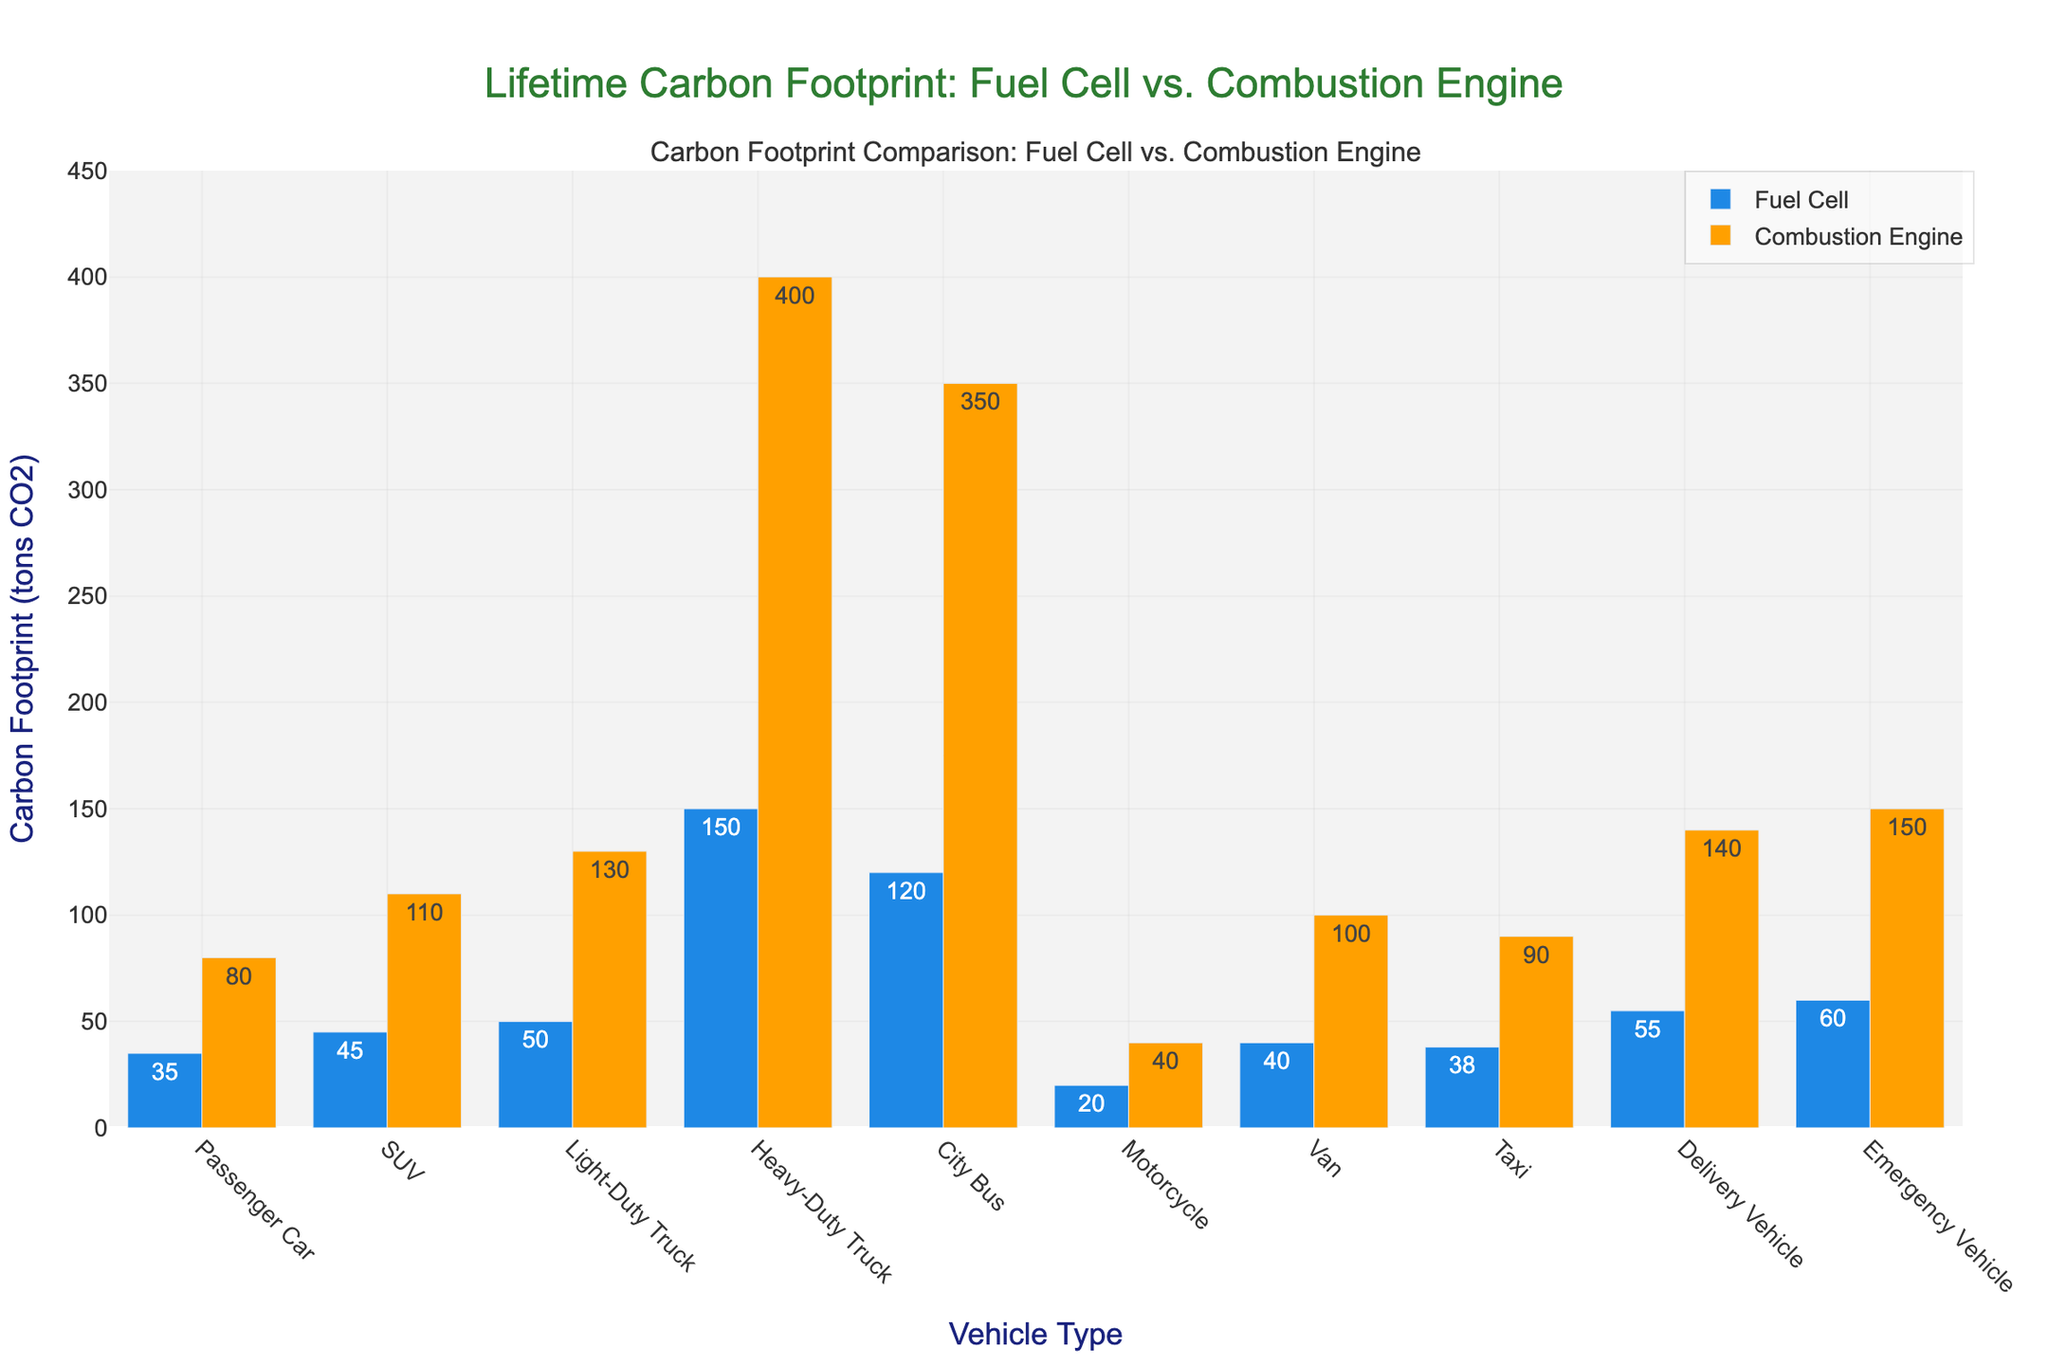What is the total carbon footprint of a fuel cell City Bus and an Emergency Vehicle combined? Sum the carbon footprint of fuel cell City Bus (120 tons CO2) and Emergency Vehicle (60 tons CO2): 120 + 60 = 180
Answer: 180 Which vehicle type shows the greatest difference in carbon footprint between fuel cell technology and combustion engine? Compare the differences for each vehicle type. Heavy-Duty Truck has the largest difference: 400 (Combustion Engine) - 150 (Fuel Cell) = 250
Answer: Heavy-Duty Truck How much more carbon does an SUV with a combustion engine emit over its lifetime compared to an SUV with a fuel cell? Subtract the carbon footprint of a fuel cell SUV (45 tons CO2) from a combustion engine SUV (110 tons CO2): 110 - 45 = 65
Answer: 65 What is the average carbon footprint of fuel cell vehicles for Passenger Car, SUV, and Light-Duty Truck? Sum the carbon footprints of these fuel cell vehicles: Passenger Car (35) + SUV (45) + Light-Duty Truck (50) = 130. Divide by 3: 130 / 3 ≈ 43.33
Answer: 43.33 Which vehicle type has the smallest carbon footprint for both fuel cell and combustion engine? Check the carbon footprints for both fuel cell and combustion engine across all vehicle types. Motorcycle has the smallest values: 20 (Fuel Cell) and 40 (Combustion Engine)
Answer: Motorcycle Between which vehicle types is the visual height difference of the bars (fuel cell vs. combustion engine) most noticeable? Visually compare bar heights for each vehicle type. Heavy-Duty Truck exhibits the most noticeable height difference with a difference of 250 tons CO2
Answer: Heavy-Duty Truck How does the carbon footprint of a fuel cell Taxi compare to that of a combustion engine Van? Compare the values directly: Fuel Cell Taxi (38 tons CO2) and Combustion Engine Van (100 tons CO2). The fuel cell Taxi emits 62 tons CO2 less
Answer: Taxi emits 62 tons CO2 less Which colored bar represents the fuel cell technology in the plotted figure? Identify the color associated with fuel cell technology in the bar graph. The blue bars represent the fuel cell technology
Answer: Blue Is the carbon footprint of a combustion engine City Bus more than triple that of a fuel cell City Bus? Compare the footprints: Combustion Engine City Bus (350 tons CO2), Fuel Cell City Bus (120 tons CO2). 3 * 120 = 360. Since 350 < 360, it is slightly less than triple
Answer: No, slightly less What is the median carbon footprint for fuel cell vehicles across all types? List the fuel cell footprints: 20 (Motorcycle), 35 (Passenger Car), 38 (Taxi), 40 (Van), 45 (SUV), 50 (Light-Duty Truck), 55 (Delivery Vehicle), 60 (Emergency Vehicle), 120 (City Bus), 150 (Heavy-Duty Truck). The middle value for 10 values is the average of the 5th and 6th values: (45 + 50) / 2 = 47.5
Answer: 47.5 